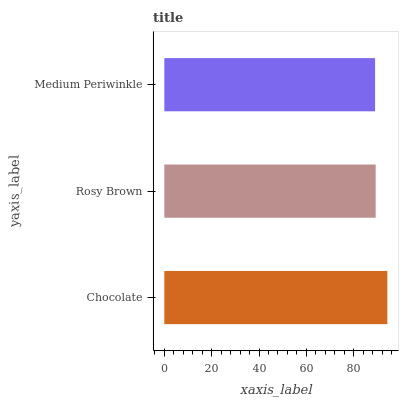Is Medium Periwinkle the minimum?
Answer yes or no. Yes. Is Chocolate the maximum?
Answer yes or no. Yes. Is Rosy Brown the minimum?
Answer yes or no. No. Is Rosy Brown the maximum?
Answer yes or no. No. Is Chocolate greater than Rosy Brown?
Answer yes or no. Yes. Is Rosy Brown less than Chocolate?
Answer yes or no. Yes. Is Rosy Brown greater than Chocolate?
Answer yes or no. No. Is Chocolate less than Rosy Brown?
Answer yes or no. No. Is Rosy Brown the high median?
Answer yes or no. Yes. Is Rosy Brown the low median?
Answer yes or no. Yes. Is Medium Periwinkle the high median?
Answer yes or no. No. Is Chocolate the low median?
Answer yes or no. No. 